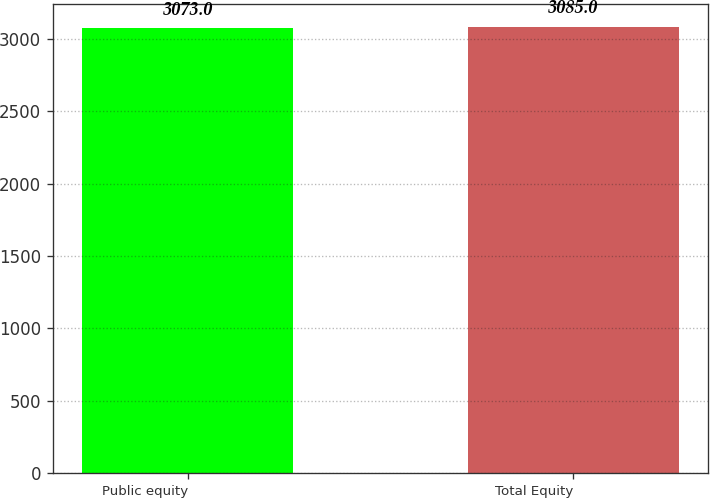<chart> <loc_0><loc_0><loc_500><loc_500><bar_chart><fcel>Public equity<fcel>Total Equity<nl><fcel>3073<fcel>3085<nl></chart> 